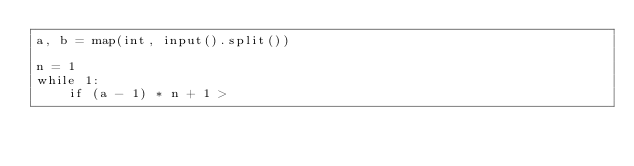Convert code to text. <code><loc_0><loc_0><loc_500><loc_500><_Python_>a, b = map(int, input().split())

n = 1
while 1:
    if (a - 1) * n + 1 ></code> 